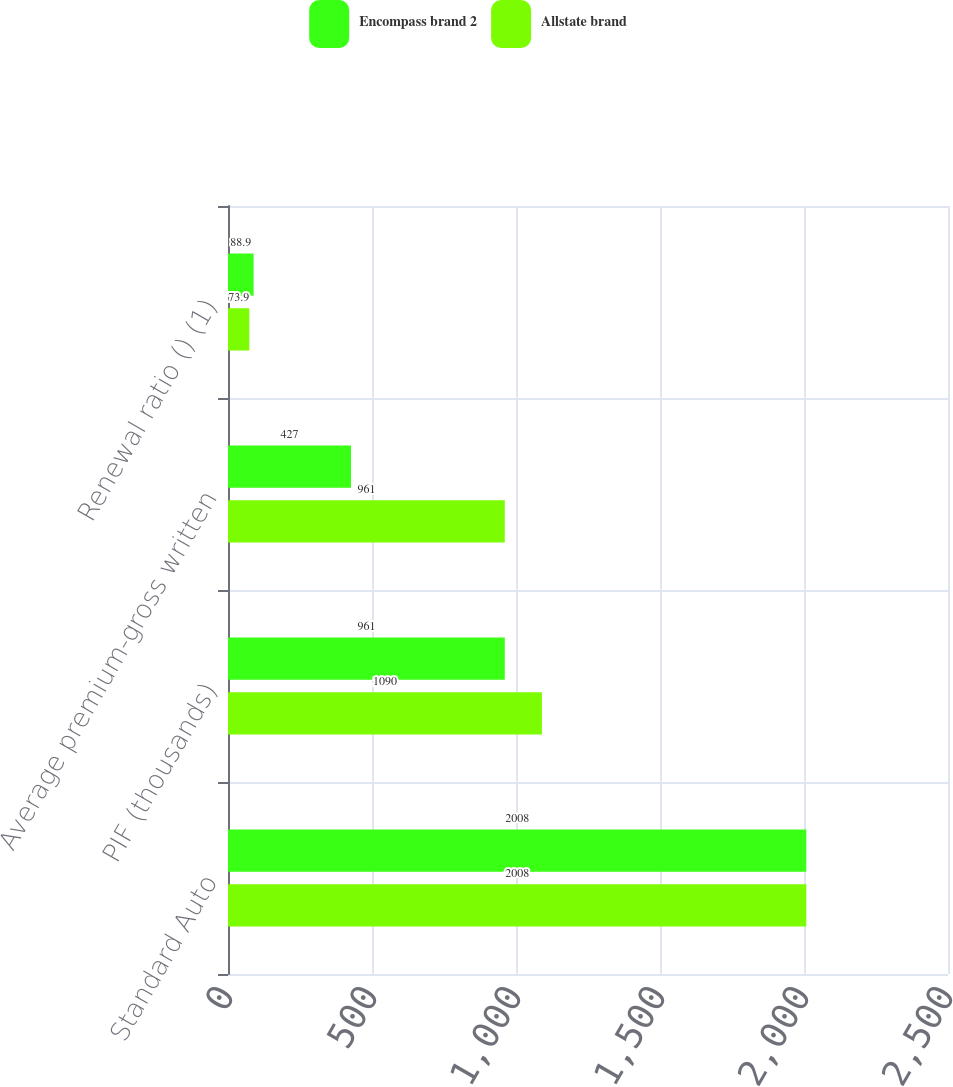Convert chart to OTSL. <chart><loc_0><loc_0><loc_500><loc_500><stacked_bar_chart><ecel><fcel>Standard Auto<fcel>PIF (thousands)<fcel>Average premium-gross written<fcel>Renewal ratio () (1)<nl><fcel>Encompass brand 2<fcel>2008<fcel>961<fcel>427<fcel>88.9<nl><fcel>Allstate brand<fcel>2008<fcel>1090<fcel>961<fcel>73.9<nl></chart> 